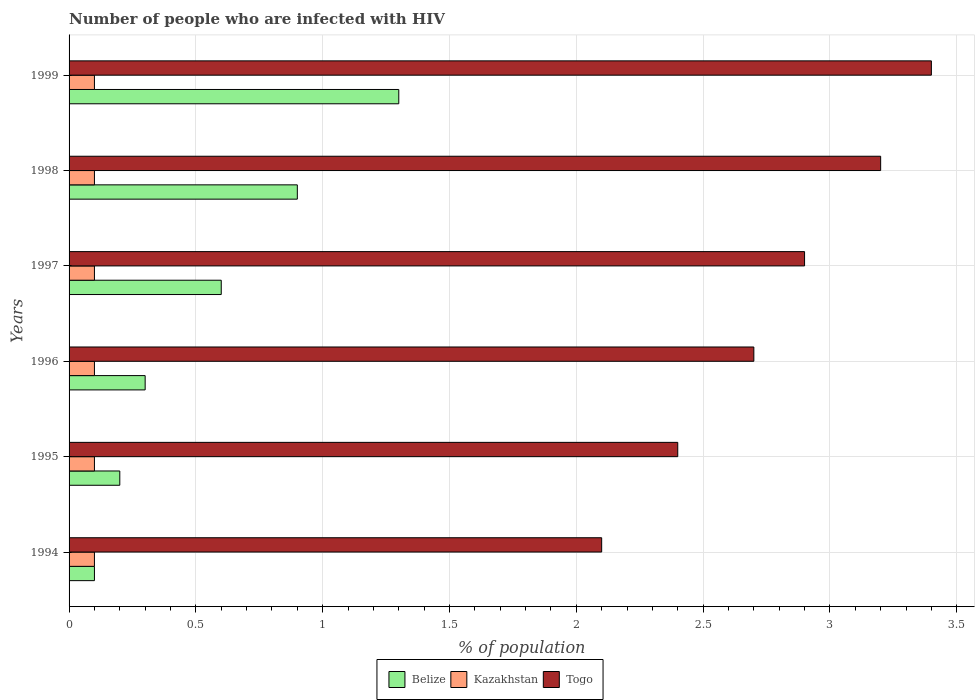How many bars are there on the 6th tick from the bottom?
Ensure brevity in your answer.  3. What is the total percentage of HIV infected population in in Kazakhstan in the graph?
Keep it short and to the point. 0.6. What is the difference between the percentage of HIV infected population in in Togo in 1994 and that in 1998?
Ensure brevity in your answer.  -1.1. What is the average percentage of HIV infected population in in Togo per year?
Provide a short and direct response. 2.78. In how many years, is the percentage of HIV infected population in in Togo greater than 0.30000000000000004 %?
Provide a short and direct response. 6. Is the difference between the percentage of HIV infected population in in Belize in 1996 and 1998 greater than the difference between the percentage of HIV infected population in in Togo in 1996 and 1998?
Your answer should be very brief. No. What is the difference between the highest and the second highest percentage of HIV infected population in in Kazakhstan?
Provide a short and direct response. 0. What is the difference between the highest and the lowest percentage of HIV infected population in in Togo?
Make the answer very short. 1.3. In how many years, is the percentage of HIV infected population in in Togo greater than the average percentage of HIV infected population in in Togo taken over all years?
Give a very brief answer. 3. Is the sum of the percentage of HIV infected population in in Kazakhstan in 1994 and 1996 greater than the maximum percentage of HIV infected population in in Togo across all years?
Offer a very short reply. No. What does the 2nd bar from the top in 1994 represents?
Your answer should be compact. Kazakhstan. What does the 3rd bar from the bottom in 1999 represents?
Offer a very short reply. Togo. Is it the case that in every year, the sum of the percentage of HIV infected population in in Kazakhstan and percentage of HIV infected population in in Togo is greater than the percentage of HIV infected population in in Belize?
Your answer should be very brief. Yes. Are all the bars in the graph horizontal?
Offer a very short reply. Yes. How many years are there in the graph?
Provide a short and direct response. 6. Does the graph contain grids?
Offer a terse response. Yes. How many legend labels are there?
Your answer should be compact. 3. What is the title of the graph?
Provide a succinct answer. Number of people who are infected with HIV. What is the label or title of the X-axis?
Your answer should be compact. % of population. What is the % of population of Kazakhstan in 1994?
Provide a succinct answer. 0.1. What is the % of population of Belize in 1995?
Give a very brief answer. 0.2. What is the % of population in Kazakhstan in 1995?
Give a very brief answer. 0.1. What is the % of population in Kazakhstan in 1996?
Offer a terse response. 0.1. What is the % of population in Togo in 1996?
Your answer should be compact. 2.7. What is the % of population of Belize in 1997?
Provide a succinct answer. 0.6. What is the % of population of Kazakhstan in 1997?
Your answer should be very brief. 0.1. What is the % of population in Togo in 1998?
Offer a very short reply. 3.2. What is the % of population in Togo in 1999?
Give a very brief answer. 3.4. Across all years, what is the maximum % of population of Belize?
Offer a very short reply. 1.3. Across all years, what is the maximum % of population in Kazakhstan?
Make the answer very short. 0.1. Across all years, what is the minimum % of population of Belize?
Give a very brief answer. 0.1. Across all years, what is the minimum % of population of Kazakhstan?
Provide a succinct answer. 0.1. Across all years, what is the minimum % of population of Togo?
Keep it short and to the point. 2.1. What is the total % of population of Belize in the graph?
Offer a terse response. 3.4. What is the total % of population in Kazakhstan in the graph?
Give a very brief answer. 0.6. What is the total % of population in Togo in the graph?
Offer a very short reply. 16.7. What is the difference between the % of population in Kazakhstan in 1994 and that in 1996?
Keep it short and to the point. 0. What is the difference between the % of population in Togo in 1994 and that in 1996?
Provide a succinct answer. -0.6. What is the difference between the % of population of Belize in 1994 and that in 1997?
Offer a very short reply. -0.5. What is the difference between the % of population of Kazakhstan in 1994 and that in 1997?
Offer a very short reply. 0. What is the difference between the % of population of Togo in 1994 and that in 1997?
Keep it short and to the point. -0.8. What is the difference between the % of population of Togo in 1994 and that in 1998?
Give a very brief answer. -1.1. What is the difference between the % of population of Belize in 1994 and that in 1999?
Offer a very short reply. -1.2. What is the difference between the % of population of Kazakhstan in 1994 and that in 1999?
Offer a very short reply. 0. What is the difference between the % of population of Belize in 1995 and that in 1997?
Keep it short and to the point. -0.4. What is the difference between the % of population of Kazakhstan in 1995 and that in 1997?
Offer a very short reply. 0. What is the difference between the % of population in Belize in 1995 and that in 1998?
Give a very brief answer. -0.7. What is the difference between the % of population in Kazakhstan in 1995 and that in 1998?
Give a very brief answer. 0. What is the difference between the % of population of Togo in 1995 and that in 1998?
Your answer should be very brief. -0.8. What is the difference between the % of population of Kazakhstan in 1995 and that in 1999?
Provide a short and direct response. 0. What is the difference between the % of population in Togo in 1995 and that in 1999?
Your response must be concise. -1. What is the difference between the % of population in Belize in 1996 and that in 1997?
Make the answer very short. -0.3. What is the difference between the % of population of Kazakhstan in 1996 and that in 1997?
Your answer should be compact. 0. What is the difference between the % of population in Togo in 1996 and that in 1997?
Provide a short and direct response. -0.2. What is the difference between the % of population of Kazakhstan in 1996 and that in 1999?
Provide a short and direct response. 0. What is the difference between the % of population in Belize in 1997 and that in 1998?
Offer a terse response. -0.3. What is the difference between the % of population in Togo in 1997 and that in 1998?
Offer a terse response. -0.3. What is the difference between the % of population of Belize in 1997 and that in 1999?
Your answer should be compact. -0.7. What is the difference between the % of population of Togo in 1997 and that in 1999?
Offer a terse response. -0.5. What is the difference between the % of population of Belize in 1998 and that in 1999?
Your answer should be very brief. -0.4. What is the difference between the % of population in Kazakhstan in 1998 and that in 1999?
Keep it short and to the point. 0. What is the difference between the % of population in Togo in 1998 and that in 1999?
Ensure brevity in your answer.  -0.2. What is the difference between the % of population in Kazakhstan in 1994 and the % of population in Togo in 1996?
Keep it short and to the point. -2.6. What is the difference between the % of population of Belize in 1994 and the % of population of Kazakhstan in 1997?
Your answer should be compact. 0. What is the difference between the % of population of Belize in 1994 and the % of population of Togo in 1997?
Give a very brief answer. -2.8. What is the difference between the % of population in Belize in 1994 and the % of population in Kazakhstan in 1999?
Ensure brevity in your answer.  0. What is the difference between the % of population of Belize in 1994 and the % of population of Togo in 1999?
Give a very brief answer. -3.3. What is the difference between the % of population of Kazakhstan in 1994 and the % of population of Togo in 1999?
Ensure brevity in your answer.  -3.3. What is the difference between the % of population in Belize in 1995 and the % of population in Kazakhstan in 1996?
Offer a very short reply. 0.1. What is the difference between the % of population of Belize in 1995 and the % of population of Togo in 1996?
Provide a succinct answer. -2.5. What is the difference between the % of population of Kazakhstan in 1995 and the % of population of Togo in 1996?
Keep it short and to the point. -2.6. What is the difference between the % of population in Belize in 1995 and the % of population in Kazakhstan in 1998?
Offer a terse response. 0.1. What is the difference between the % of population in Belize in 1995 and the % of population in Togo in 1998?
Provide a short and direct response. -3. What is the difference between the % of population of Kazakhstan in 1995 and the % of population of Togo in 1998?
Offer a very short reply. -3.1. What is the difference between the % of population in Belize in 1995 and the % of population in Kazakhstan in 1999?
Your response must be concise. 0.1. What is the difference between the % of population of Kazakhstan in 1995 and the % of population of Togo in 1999?
Ensure brevity in your answer.  -3.3. What is the difference between the % of population in Belize in 1996 and the % of population in Kazakhstan in 1997?
Offer a very short reply. 0.2. What is the difference between the % of population of Kazakhstan in 1996 and the % of population of Togo in 1997?
Offer a terse response. -2.8. What is the difference between the % of population of Belize in 1996 and the % of population of Togo in 1999?
Your answer should be very brief. -3.1. What is the difference between the % of population of Belize in 1997 and the % of population of Togo in 1998?
Offer a terse response. -2.6. What is the difference between the % of population in Kazakhstan in 1997 and the % of population in Togo in 1998?
Offer a very short reply. -3.1. What is the difference between the % of population of Kazakhstan in 1997 and the % of population of Togo in 1999?
Provide a succinct answer. -3.3. What is the difference between the % of population in Belize in 1998 and the % of population in Togo in 1999?
Offer a terse response. -2.5. What is the difference between the % of population in Kazakhstan in 1998 and the % of population in Togo in 1999?
Provide a succinct answer. -3.3. What is the average % of population in Belize per year?
Your response must be concise. 0.57. What is the average % of population of Kazakhstan per year?
Provide a short and direct response. 0.1. What is the average % of population of Togo per year?
Ensure brevity in your answer.  2.78. In the year 1994, what is the difference between the % of population of Belize and % of population of Togo?
Your answer should be compact. -2. In the year 1995, what is the difference between the % of population in Belize and % of population in Kazakhstan?
Make the answer very short. 0.1. In the year 1995, what is the difference between the % of population of Kazakhstan and % of population of Togo?
Ensure brevity in your answer.  -2.3. In the year 1996, what is the difference between the % of population in Kazakhstan and % of population in Togo?
Keep it short and to the point. -2.6. In the year 1997, what is the difference between the % of population of Belize and % of population of Kazakhstan?
Give a very brief answer. 0.5. What is the ratio of the % of population in Belize in 1994 to that in 1995?
Provide a succinct answer. 0.5. What is the ratio of the % of population of Kazakhstan in 1994 to that in 1995?
Keep it short and to the point. 1. What is the ratio of the % of population of Kazakhstan in 1994 to that in 1996?
Offer a very short reply. 1. What is the ratio of the % of population in Togo in 1994 to that in 1996?
Your answer should be compact. 0.78. What is the ratio of the % of population of Togo in 1994 to that in 1997?
Provide a succinct answer. 0.72. What is the ratio of the % of population in Kazakhstan in 1994 to that in 1998?
Provide a succinct answer. 1. What is the ratio of the % of population of Togo in 1994 to that in 1998?
Offer a very short reply. 0.66. What is the ratio of the % of population in Belize in 1994 to that in 1999?
Ensure brevity in your answer.  0.08. What is the ratio of the % of population in Kazakhstan in 1994 to that in 1999?
Keep it short and to the point. 1. What is the ratio of the % of population in Togo in 1994 to that in 1999?
Ensure brevity in your answer.  0.62. What is the ratio of the % of population of Kazakhstan in 1995 to that in 1996?
Offer a very short reply. 1. What is the ratio of the % of population in Belize in 1995 to that in 1997?
Make the answer very short. 0.33. What is the ratio of the % of population of Togo in 1995 to that in 1997?
Make the answer very short. 0.83. What is the ratio of the % of population in Belize in 1995 to that in 1998?
Make the answer very short. 0.22. What is the ratio of the % of population in Kazakhstan in 1995 to that in 1998?
Your answer should be compact. 1. What is the ratio of the % of population in Belize in 1995 to that in 1999?
Offer a terse response. 0.15. What is the ratio of the % of population in Kazakhstan in 1995 to that in 1999?
Your response must be concise. 1. What is the ratio of the % of population in Togo in 1995 to that in 1999?
Make the answer very short. 0.71. What is the ratio of the % of population in Togo in 1996 to that in 1998?
Offer a very short reply. 0.84. What is the ratio of the % of population of Belize in 1996 to that in 1999?
Your answer should be compact. 0.23. What is the ratio of the % of population of Kazakhstan in 1996 to that in 1999?
Offer a very short reply. 1. What is the ratio of the % of population of Togo in 1996 to that in 1999?
Your answer should be compact. 0.79. What is the ratio of the % of population in Kazakhstan in 1997 to that in 1998?
Offer a very short reply. 1. What is the ratio of the % of population in Togo in 1997 to that in 1998?
Your answer should be very brief. 0.91. What is the ratio of the % of population of Belize in 1997 to that in 1999?
Make the answer very short. 0.46. What is the ratio of the % of population in Kazakhstan in 1997 to that in 1999?
Provide a succinct answer. 1. What is the ratio of the % of population in Togo in 1997 to that in 1999?
Provide a short and direct response. 0.85. What is the ratio of the % of population of Belize in 1998 to that in 1999?
Ensure brevity in your answer.  0.69. What is the ratio of the % of population in Togo in 1998 to that in 1999?
Your answer should be compact. 0.94. What is the difference between the highest and the second highest % of population of Kazakhstan?
Provide a succinct answer. 0. What is the difference between the highest and the second highest % of population in Togo?
Make the answer very short. 0.2. What is the difference between the highest and the lowest % of population of Belize?
Your answer should be very brief. 1.2. 